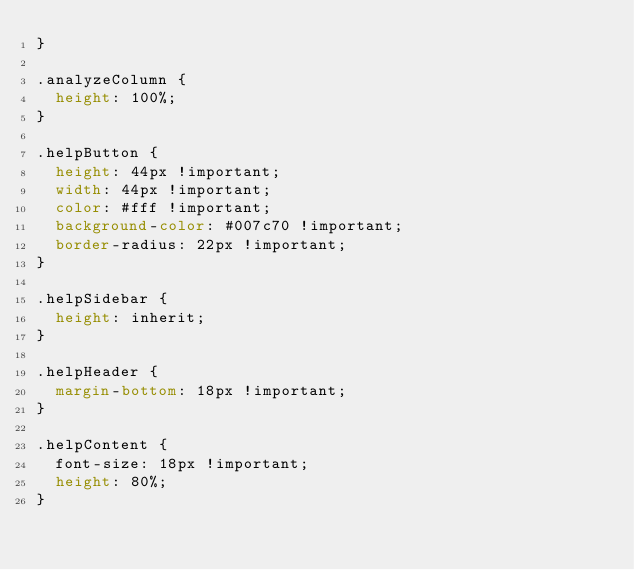<code> <loc_0><loc_0><loc_500><loc_500><_CSS_>}

.analyzeColumn {
  height: 100%;
}

.helpButton {
  height: 44px !important;
  width: 44px !important;
  color: #fff !important;
  background-color: #007c70 !important;
  border-radius: 22px !important;
}

.helpSidebar {
  height: inherit;
}

.helpHeader {
  margin-bottom: 18px !important;
}

.helpContent {
  font-size: 18px !important;
  height: 80%;
}
</code> 